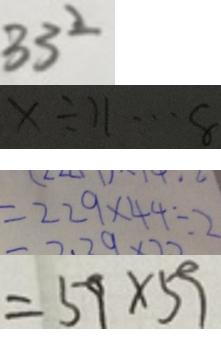<formula> <loc_0><loc_0><loc_500><loc_500>3 3 ^ { 2 } 
 x \div 1 1 \cdots 8 
 = 2 2 9 \times 4 4 \div 2 
 = 5 9 \times 5 9</formula> 